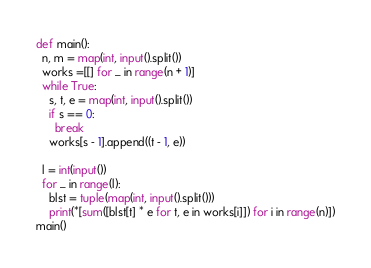<code> <loc_0><loc_0><loc_500><loc_500><_Python_>def main():
  n, m = map(int, input().split())
  works =[[] for _ in range(n + 1)]
  while True:
    s, t, e = map(int, input().split())
    if s == 0:
      break
    works[s - 1].append((t - 1, e))
  
  l = int(input())
  for _ in range(l):
    blst = tuple(map(int, input().split()))
    print(*[sum([blst[t] * e for t, e in works[i]]) for i in range(n)])
main()
</code> 